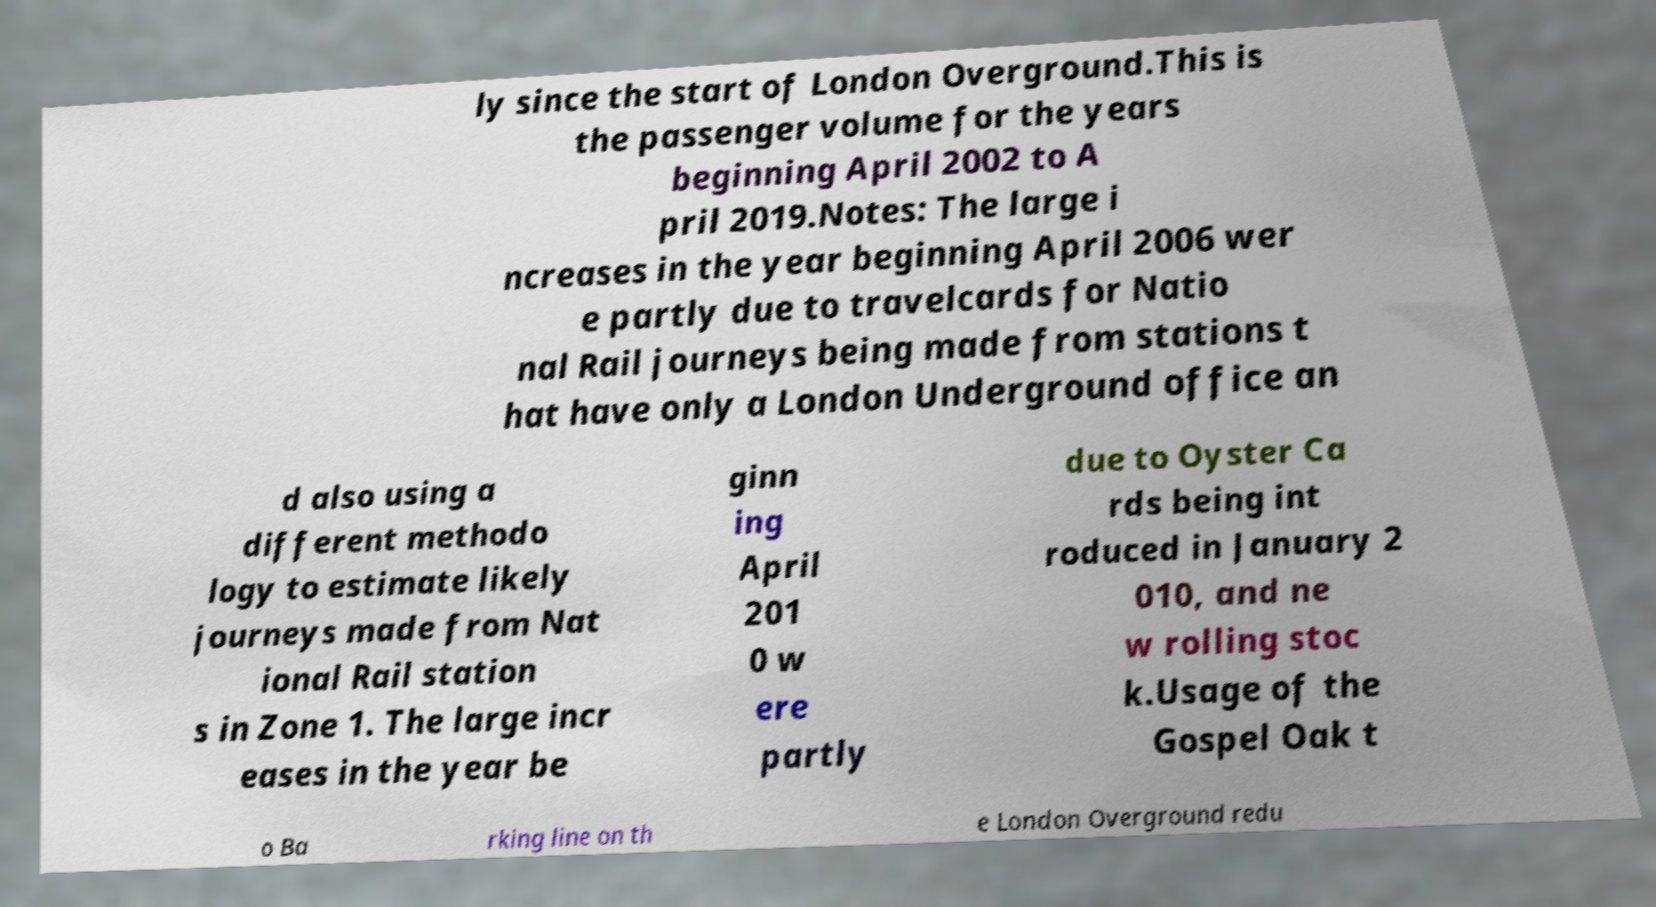I need the written content from this picture converted into text. Can you do that? ly since the start of London Overground.This is the passenger volume for the years beginning April 2002 to A pril 2019.Notes: The large i ncreases in the year beginning April 2006 wer e partly due to travelcards for Natio nal Rail journeys being made from stations t hat have only a London Underground office an d also using a different methodo logy to estimate likely journeys made from Nat ional Rail station s in Zone 1. The large incr eases in the year be ginn ing April 201 0 w ere partly due to Oyster Ca rds being int roduced in January 2 010, and ne w rolling stoc k.Usage of the Gospel Oak t o Ba rking line on th e London Overground redu 